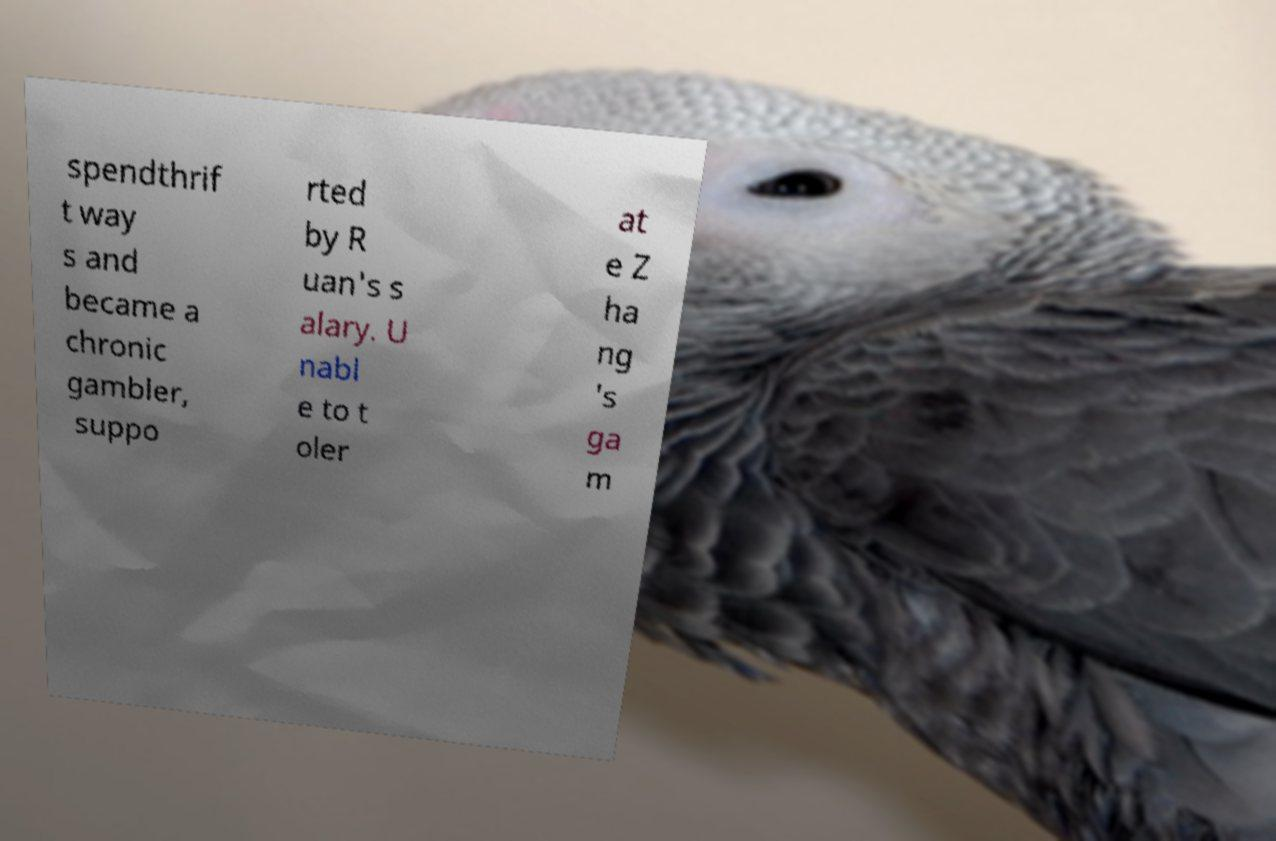Could you assist in decoding the text presented in this image and type it out clearly? spendthrif t way s and became a chronic gambler, suppo rted by R uan's s alary. U nabl e to t oler at e Z ha ng 's ga m 